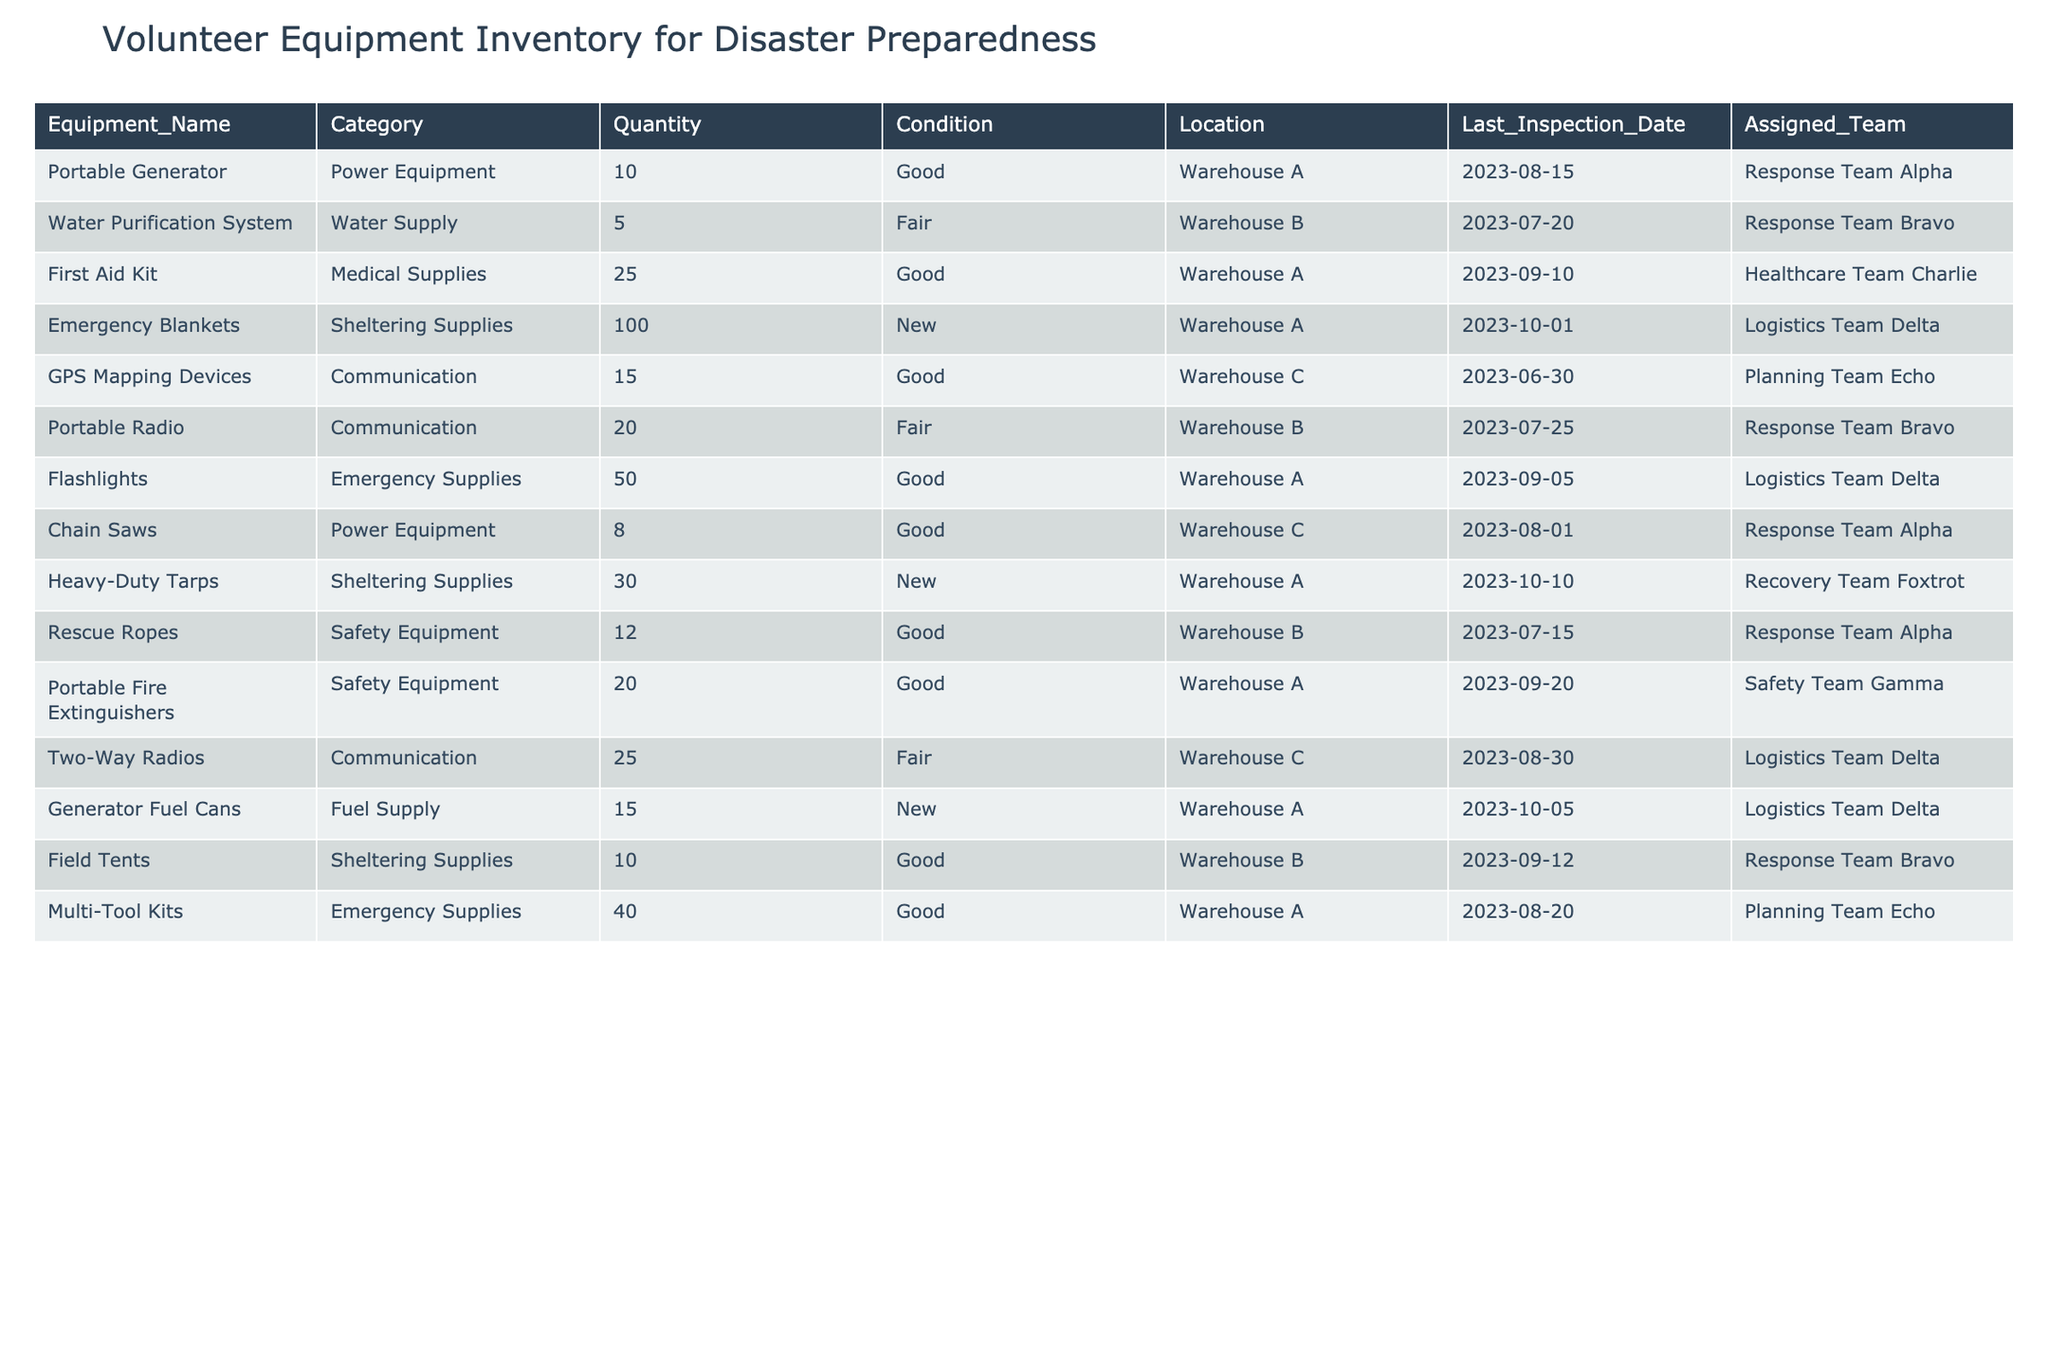What is the total quantity of equipment under "Communication" category? There are two entries under the "Communication" category: "GPS Mapping Devices" with a quantity of 15 and "Two-Way Radios" with a quantity of 25. Adding these together gives 15 + 25 = 40.
Answer: 40 Which team is assigned the most equipment? To find the team with the most equipment, we need to count the quantity for each assigned team: Response Team Alpha (10 + 8 + 12 = 30), Response Team Bravo (5 + 20 + 10 = 35), Healthcare Team Charlie (25 = 25), Logistics Team Delta (100 + 20 + 15 + 40 = 175), Recovery Team Foxtrot (30 = 30) and Safety Team Gamma (20 = 20). The team with the highest total is Logistics Team Delta with 175 units of equipment.
Answer: Logistics Team Delta Are all the "Sheltering Supplies" in new condition? There are two entries under "Sheltering Supplies": "Emergency Blankets" with "New" condition and "Heavy-Duty Tarps" which also have "New" condition. Since both entries are marked as "New", the answer is yes.
Answer: Yes What percentage of the total inventory is made up of "Good" condition equipment? To find the percentage, first count the total quantity of all equipment: 10 + 5 + 25 + 100 + 15 + 20 + 50 + 8 + 30 + 12 + 20 + 25 + 15 + 10 + 40 = 420. Next, sum the quantities of "Good" condition equipment: 10 + 25 + 100 + 15 + 8 + 12 + 20 + 40 = 240. The percentage is calculated as (240 / 420) * 100 = 57.14%.
Answer: 57.14% How many pieces of equipment are located in Warehouse C? There are three items listed in Warehouse C: "GPS Mapping Devices" (15), "Chain Saws" (8), and "Two-Way Radios" (25). By adding these quantities, we get 15 + 8 + 25 = 48 pieces of equipment.
Answer: 48 